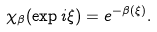<formula> <loc_0><loc_0><loc_500><loc_500>\chi _ { \beta } ( \exp { i \xi } ) = e ^ { - \beta ( \xi ) } .</formula> 